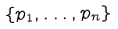Convert formula to latex. <formula><loc_0><loc_0><loc_500><loc_500>\{ { p } _ { 1 } , \dots , { p } _ { n } \}</formula> 